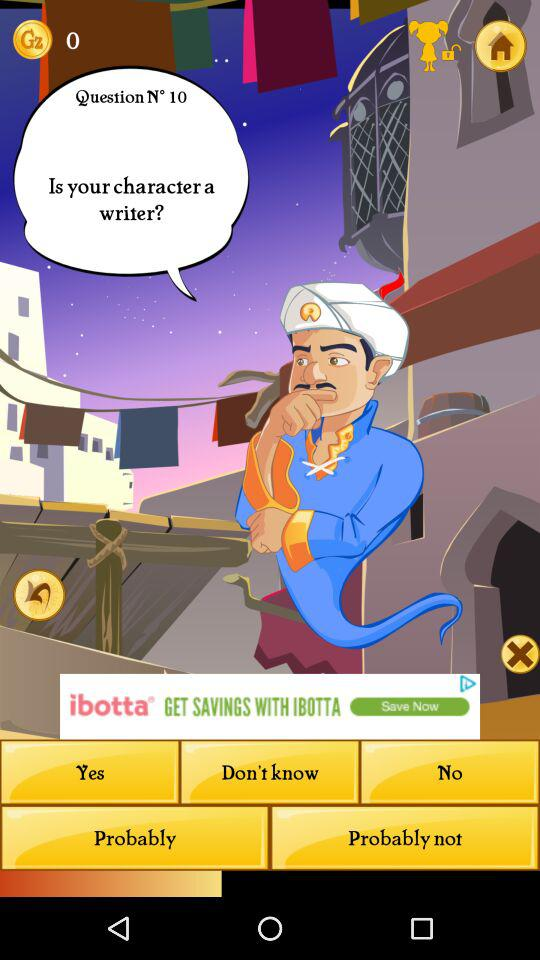How many credit points are there on the screen? There are 0 credit points on the screen. 